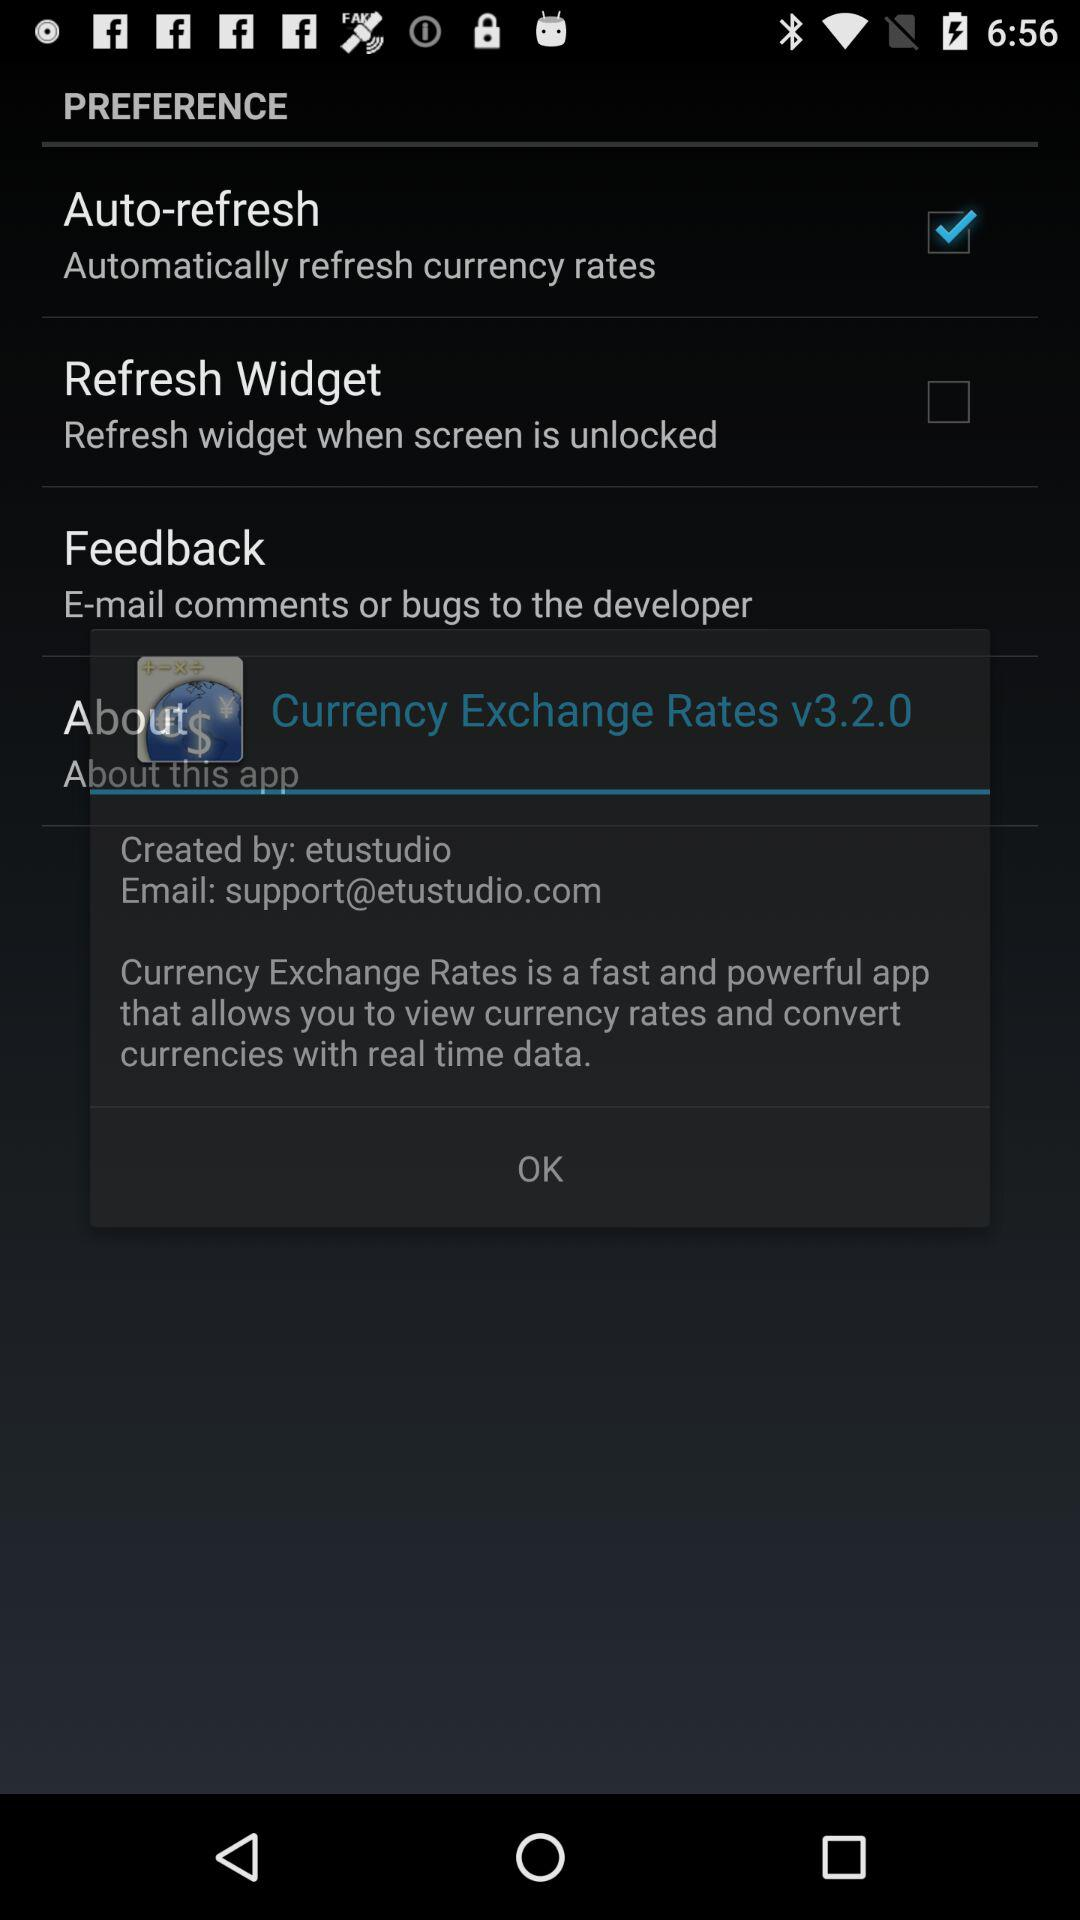Which two countries' currency graphs are given? Currency graphs for the USD and EUR are given. 